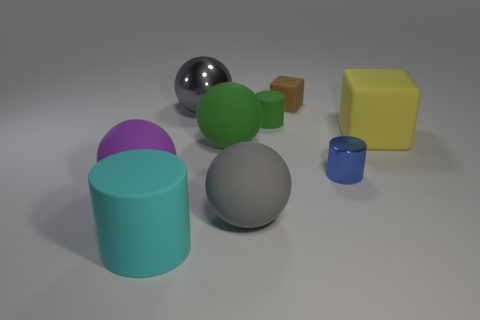Subtract all big matte spheres. How many spheres are left? 1 Subtract all gray cylinders. How many gray spheres are left? 2 Subtract all cubes. How many objects are left? 7 Subtract all green spheres. How many spheres are left? 3 Add 6 large gray rubber spheres. How many large gray rubber spheres are left? 7 Add 5 red shiny blocks. How many red shiny blocks exist? 5 Subtract 1 purple balls. How many objects are left? 8 Subtract all brown cylinders. Subtract all yellow balls. How many cylinders are left? 3 Subtract all large objects. Subtract all brown rubber balls. How many objects are left? 3 